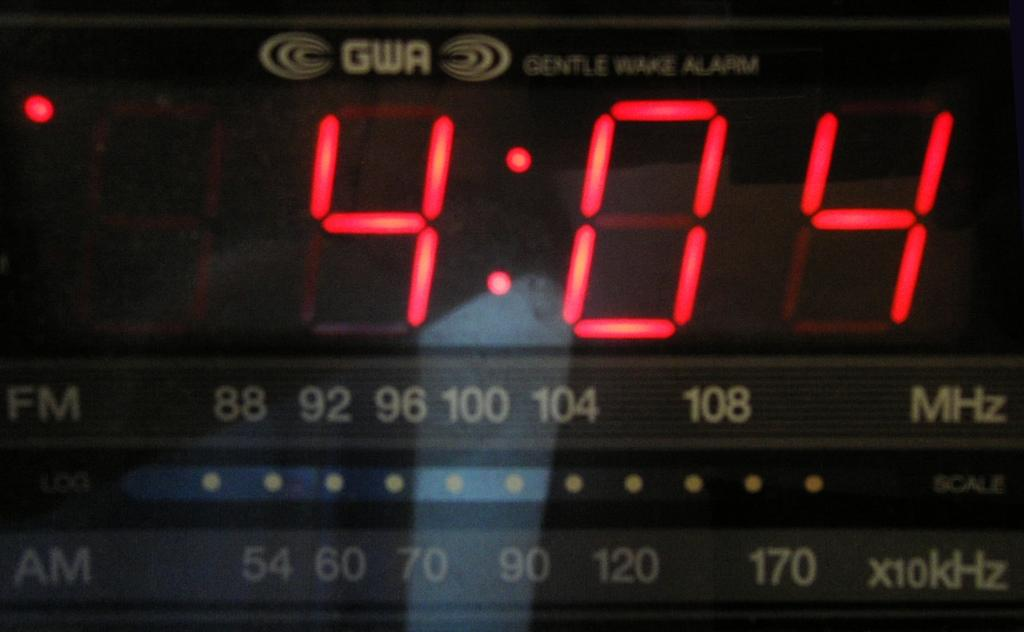<image>
Relay a brief, clear account of the picture shown. The GWA alarm clock show that the time is 4:04. 